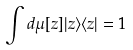Convert formula to latex. <formula><loc_0><loc_0><loc_500><loc_500>\int d \mu [ z ] | z \rangle \langle z | = 1</formula> 